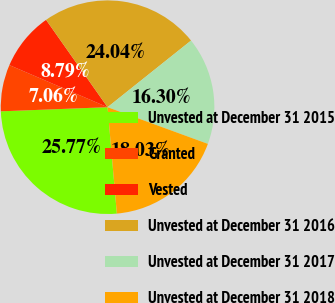Convert chart to OTSL. <chart><loc_0><loc_0><loc_500><loc_500><pie_chart><fcel>Unvested at December 31 2015<fcel>Granted<fcel>Vested<fcel>Unvested at December 31 2016<fcel>Unvested at December 31 2017<fcel>Unvested at December 31 2018<nl><fcel>25.77%<fcel>7.06%<fcel>8.79%<fcel>24.04%<fcel>16.3%<fcel>18.03%<nl></chart> 